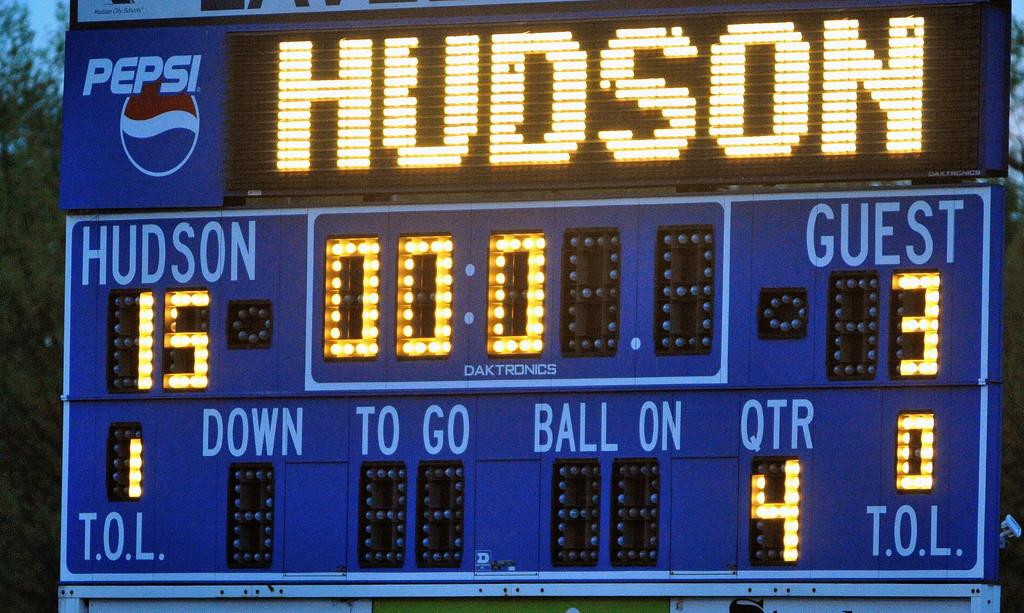<image>
Create a compact narrative representing the image presented. The score at the football game is Hudson 15 Guest 3. 